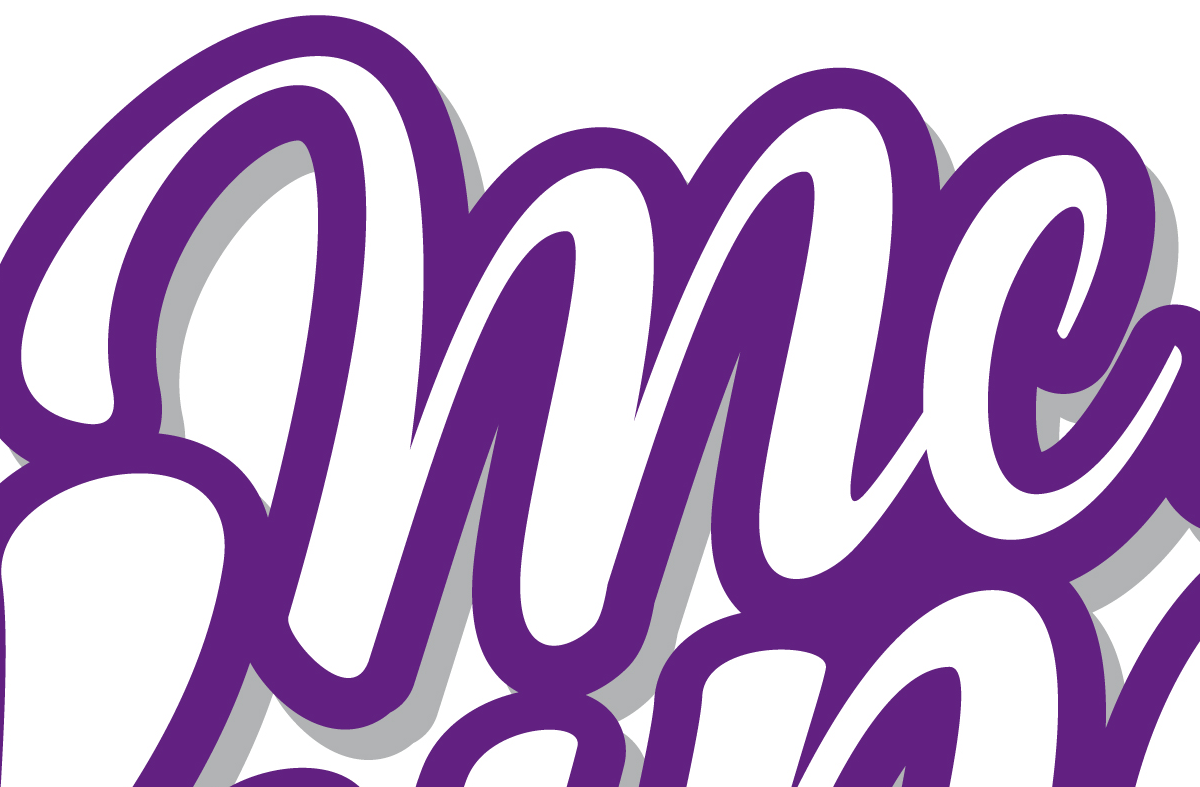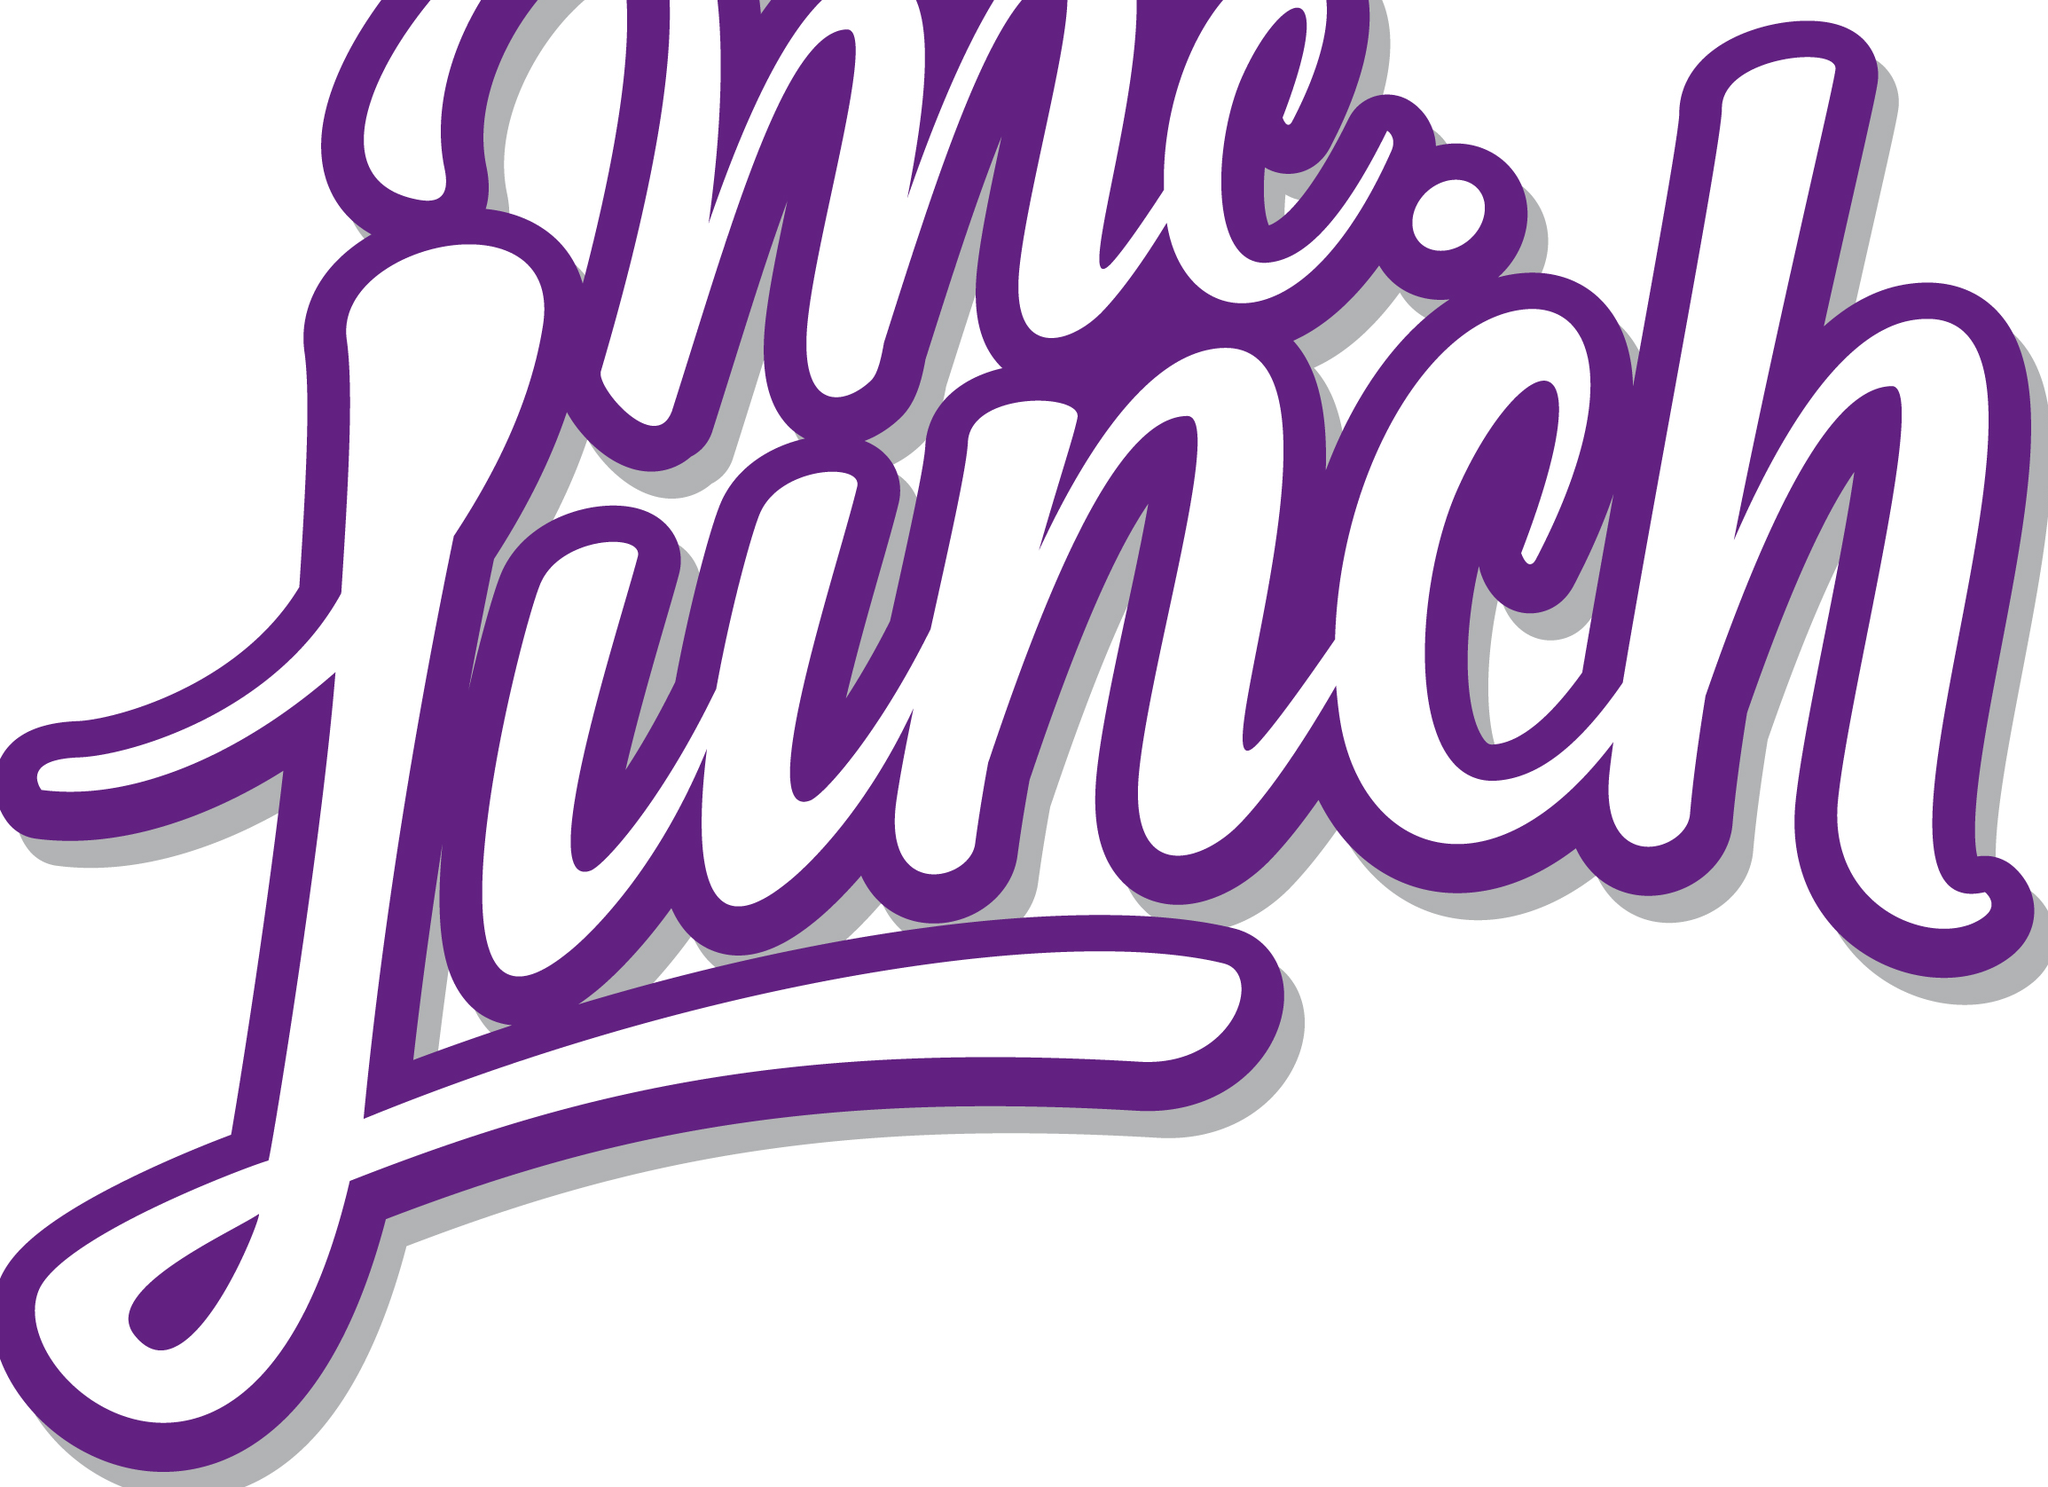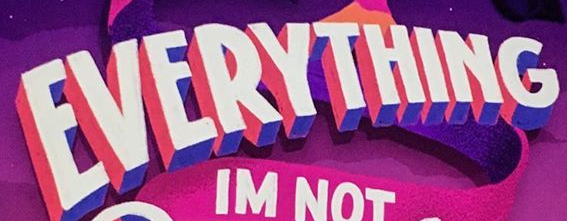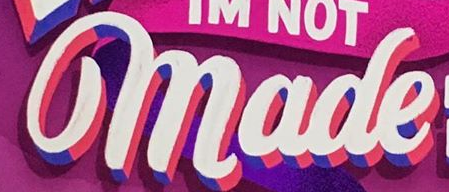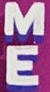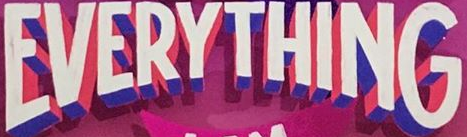Identify the words shown in these images in order, separated by a semicolon. mc; Lunch; EVERYTHING; made; ME; EVERYTHING 